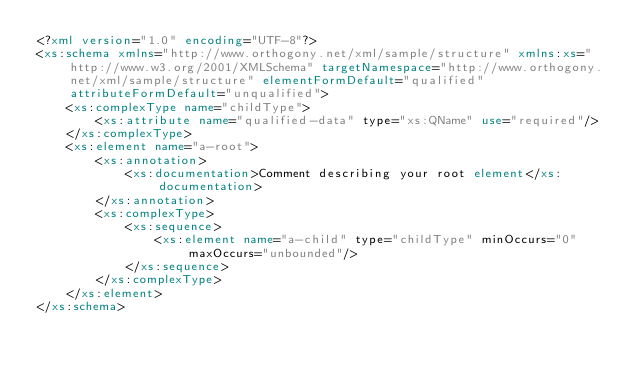<code> <loc_0><loc_0><loc_500><loc_500><_XML_><?xml version="1.0" encoding="UTF-8"?>
<xs:schema xmlns="http://www.orthogony.net/xml/sample/structure" xmlns:xs="http://www.w3.org/2001/XMLSchema" targetNamespace="http://www.orthogony.net/xml/sample/structure" elementFormDefault="qualified" attributeFormDefault="unqualified">
	<xs:complexType name="childType">
		<xs:attribute name="qualified-data" type="xs:QName" use="required"/>
	</xs:complexType>
	<xs:element name="a-root">
		<xs:annotation>
			<xs:documentation>Comment describing your root element</xs:documentation>
		</xs:annotation>
		<xs:complexType>
			<xs:sequence>
				<xs:element name="a-child" type="childType" minOccurs="0" maxOccurs="unbounded"/>
			</xs:sequence>
		</xs:complexType>
	</xs:element>
</xs:schema>
</code> 